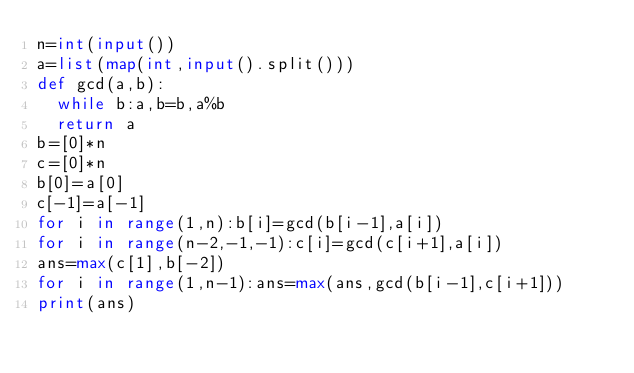<code> <loc_0><loc_0><loc_500><loc_500><_Python_>n=int(input())
a=list(map(int,input().split()))
def gcd(a,b):
  while b:a,b=b,a%b
  return a
b=[0]*n
c=[0]*n
b[0]=a[0]
c[-1]=a[-1]
for i in range(1,n):b[i]=gcd(b[i-1],a[i])
for i in range(n-2,-1,-1):c[i]=gcd(c[i+1],a[i])
ans=max(c[1],b[-2])
for i in range(1,n-1):ans=max(ans,gcd(b[i-1],c[i+1]))
print(ans)</code> 